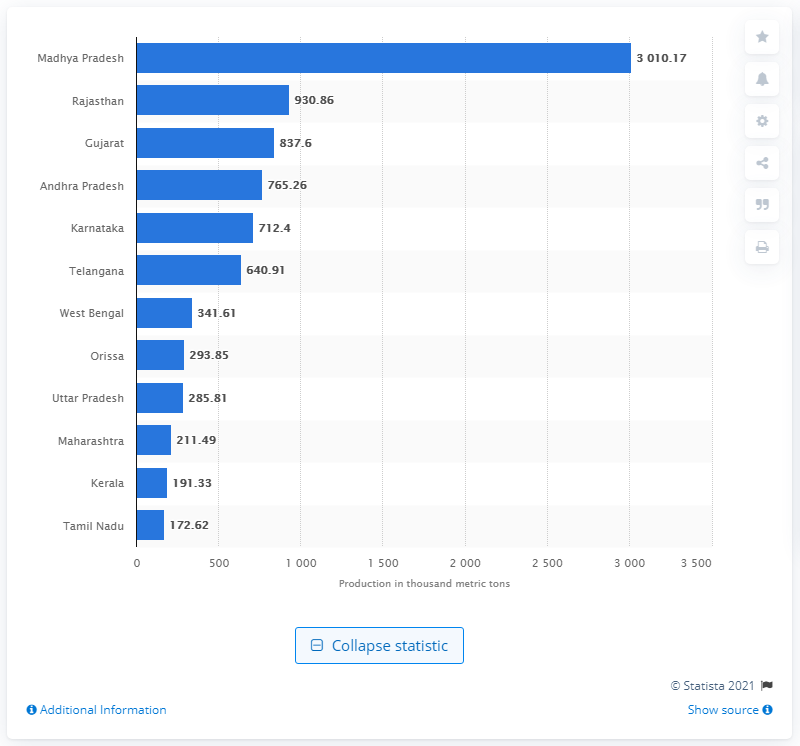Highlight a few significant elements in this photo. Madhya Pradesh was the largest producer of spices in India in 2020. 